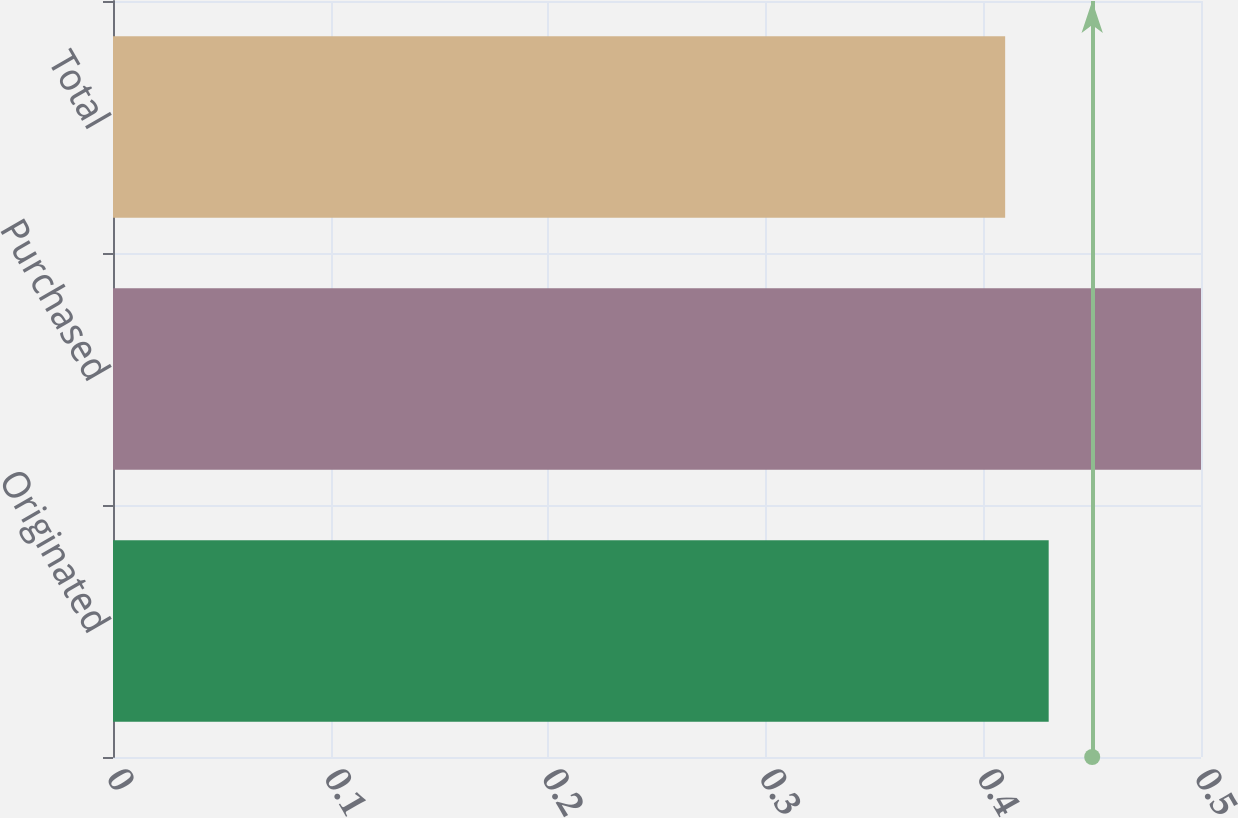Convert chart. <chart><loc_0><loc_0><loc_500><loc_500><bar_chart><fcel>Originated<fcel>Purchased<fcel>Total<nl><fcel>0.43<fcel>0.5<fcel>0.41<nl></chart> 